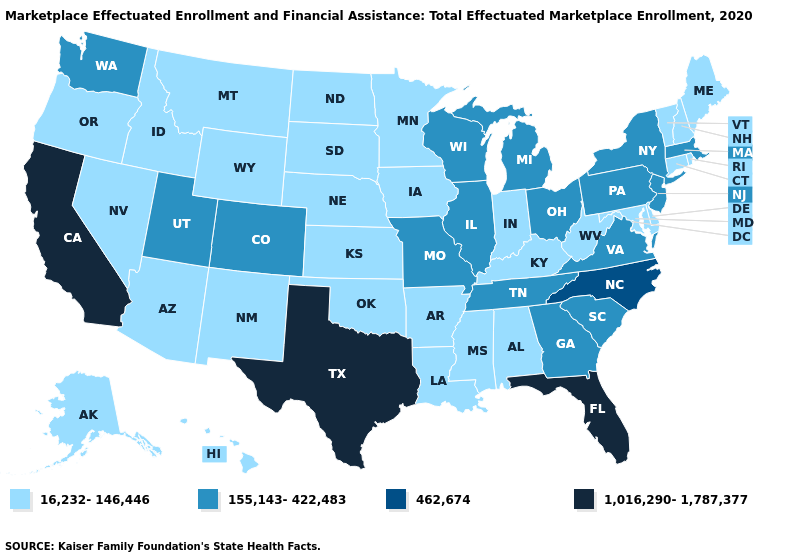Which states have the lowest value in the West?
Concise answer only. Alaska, Arizona, Hawaii, Idaho, Montana, Nevada, New Mexico, Oregon, Wyoming. What is the lowest value in the USA?
Be succinct. 16,232-146,446. Name the states that have a value in the range 1,016,290-1,787,377?
Concise answer only. California, Florida, Texas. What is the value of Delaware?
Short answer required. 16,232-146,446. Does Minnesota have a higher value than South Carolina?
Short answer required. No. Which states have the lowest value in the USA?
Write a very short answer. Alabama, Alaska, Arizona, Arkansas, Connecticut, Delaware, Hawaii, Idaho, Indiana, Iowa, Kansas, Kentucky, Louisiana, Maine, Maryland, Minnesota, Mississippi, Montana, Nebraska, Nevada, New Hampshire, New Mexico, North Dakota, Oklahoma, Oregon, Rhode Island, South Dakota, Vermont, West Virginia, Wyoming. What is the lowest value in the South?
Give a very brief answer. 16,232-146,446. What is the value of Montana?
Keep it brief. 16,232-146,446. Does the first symbol in the legend represent the smallest category?
Concise answer only. Yes. What is the lowest value in the USA?
Write a very short answer. 16,232-146,446. How many symbols are there in the legend?
Short answer required. 4. Name the states that have a value in the range 155,143-422,483?
Give a very brief answer. Colorado, Georgia, Illinois, Massachusetts, Michigan, Missouri, New Jersey, New York, Ohio, Pennsylvania, South Carolina, Tennessee, Utah, Virginia, Washington, Wisconsin. Which states have the lowest value in the South?
Be succinct. Alabama, Arkansas, Delaware, Kentucky, Louisiana, Maryland, Mississippi, Oklahoma, West Virginia. Which states have the highest value in the USA?
Keep it brief. California, Florida, Texas. Does Kansas have the highest value in the USA?
Keep it brief. No. 